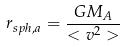Convert formula to latex. <formula><loc_0><loc_0><loc_500><loc_500>r _ { s p h , a } = \frac { G M _ { A } } { < v ^ { 2 } > }</formula> 